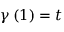Convert formula to latex. <formula><loc_0><loc_0><loc_500><loc_500>\gamma \left ( 1 \right ) = t</formula> 